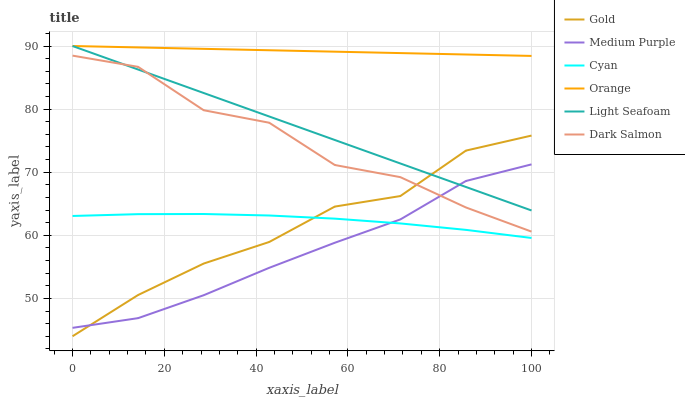Does Medium Purple have the minimum area under the curve?
Answer yes or no. Yes. Does Orange have the maximum area under the curve?
Answer yes or no. Yes. Does Dark Salmon have the minimum area under the curve?
Answer yes or no. No. Does Dark Salmon have the maximum area under the curve?
Answer yes or no. No. Is Light Seafoam the smoothest?
Answer yes or no. Yes. Is Dark Salmon the roughest?
Answer yes or no. Yes. Is Medium Purple the smoothest?
Answer yes or no. No. Is Medium Purple the roughest?
Answer yes or no. No. Does Gold have the lowest value?
Answer yes or no. Yes. Does Dark Salmon have the lowest value?
Answer yes or no. No. Does Light Seafoam have the highest value?
Answer yes or no. Yes. Does Dark Salmon have the highest value?
Answer yes or no. No. Is Medium Purple less than Orange?
Answer yes or no. Yes. Is Orange greater than Cyan?
Answer yes or no. Yes. Does Medium Purple intersect Light Seafoam?
Answer yes or no. Yes. Is Medium Purple less than Light Seafoam?
Answer yes or no. No. Is Medium Purple greater than Light Seafoam?
Answer yes or no. No. Does Medium Purple intersect Orange?
Answer yes or no. No. 